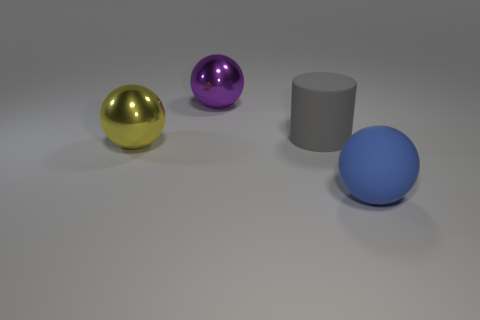Subtract all metallic spheres. How many spheres are left? 1 Subtract all spheres. How many objects are left? 1 Add 2 big red rubber cylinders. How many objects exist? 6 Subtract 1 balls. How many balls are left? 2 Subtract all gray balls. How many purple cylinders are left? 0 Subtract 0 cyan cubes. How many objects are left? 4 Subtract all cyan balls. Subtract all blue cylinders. How many balls are left? 3 Subtract all big cylinders. Subtract all large purple matte spheres. How many objects are left? 3 Add 4 metal things. How many metal things are left? 6 Add 1 large purple spheres. How many large purple spheres exist? 2 